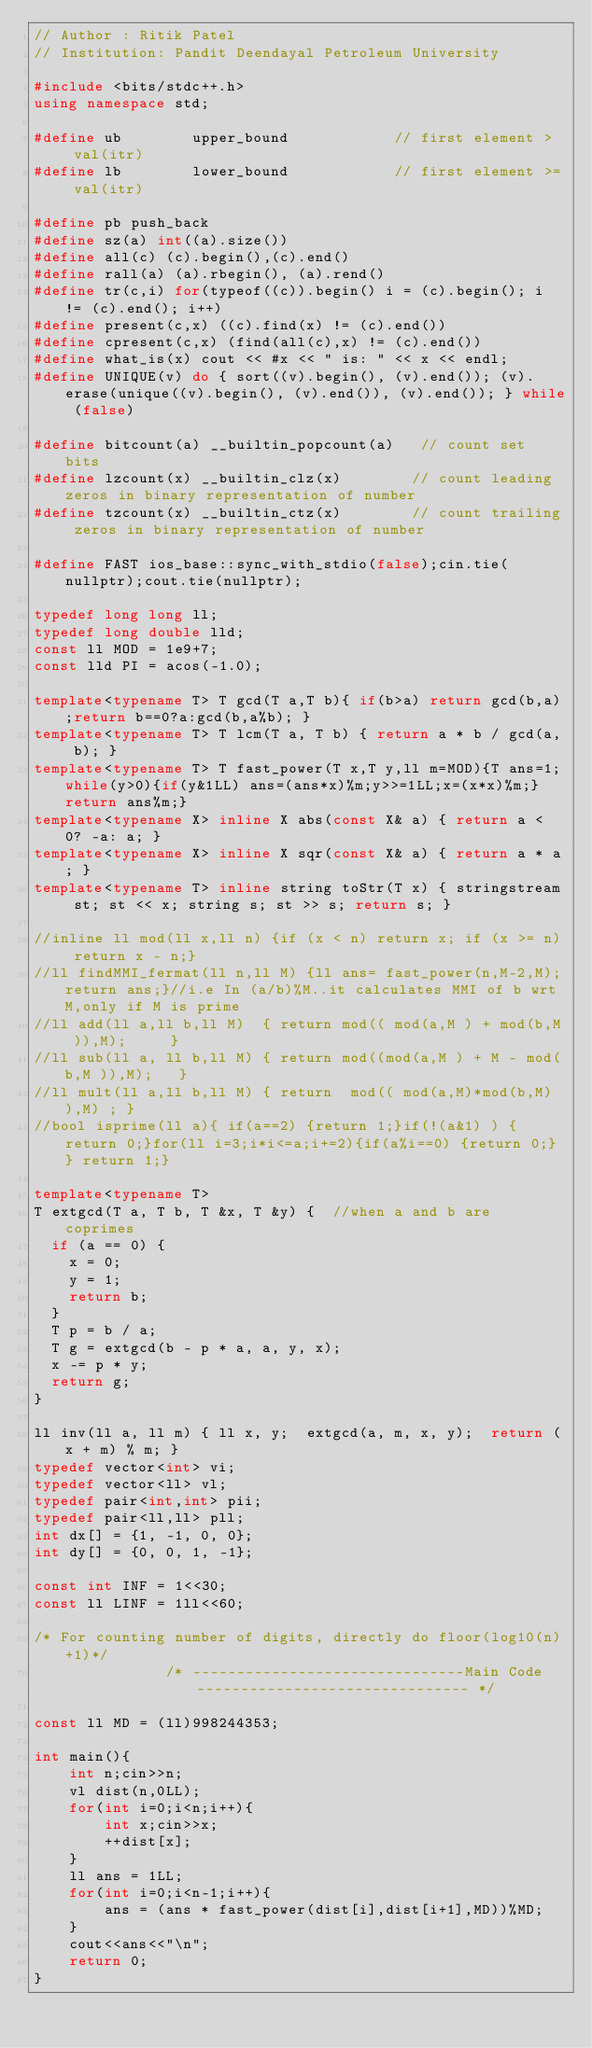<code> <loc_0><loc_0><loc_500><loc_500><_C++_>// Author : Ritik Patel
// Institution: Pandit Deendayal Petroleum University
 
#include <bits/stdc++.h>
using namespace std;
 
#define ub        upper_bound            // first element >  val(itr)
#define lb        lower_bound            // first element >= val(itr)
 
#define pb push_back 
#define sz(a) int((a).size())
#define all(c) (c).begin(),(c).end()
#define rall(a) (a).rbegin(), (a).rend()
#define tr(c,i) for(typeof((c)).begin() i = (c).begin(); i != (c).end(); i++)
#define present(c,x) ((c).find(x) != (c).end()) 
#define cpresent(c,x) (find(all(c),x) != (c).end()) 
#define what_is(x) cout << #x << " is: " << x << endl;
#define UNIQUE(v) do { sort((v).begin(), (v).end()); (v).erase(unique((v).begin(), (v).end()), (v).end()); } while (false)
 
#define bitcount(a) __builtin_popcount(a)   // count set bits
#define lzcount(x) __builtin_clz(x)        // count leading zeros in binary representation of number
#define tzcount(x) __builtin_ctz(x)        // count trailing zeros in binary representation of number
 
#define FAST ios_base::sync_with_stdio(false);cin.tie(nullptr);cout.tie(nullptr);
 
typedef long long ll;
typedef long double lld;
const ll MOD = 1e9+7;
const lld PI = acos(-1.0);
 
template<typename T> T gcd(T a,T b){ if(b>a) return gcd(b,a);return b==0?a:gcd(b,a%b); }
template<typename T> T lcm(T a, T b) { return a * b / gcd(a, b); }
template<typename T> T fast_power(T x,T y,ll m=MOD){T ans=1;while(y>0){if(y&1LL) ans=(ans*x)%m;y>>=1LL;x=(x*x)%m;}return ans%m;}
template<typename X> inline X abs(const X& a) { return a < 0? -a: a; }
template<typename X> inline X sqr(const X& a) { return a * a; }
template<typename T> inline string toStr(T x) { stringstream st; st << x; string s; st >> s; return s; }
 
//inline ll mod(ll x,ll n) {if (x < n) return x; if (x >= n) return x - n;}
//ll findMMI_fermat(ll n,ll M) {ll ans= fast_power(n,M-2,M);return ans;}//i.e In (a/b)%M..it calculates MMI of b wrt M,only if M is prime
//ll add(ll a,ll b,ll M)  { return mod(( mod(a,M ) + mod(b,M )),M);     }
//ll sub(ll a, ll b,ll M) { return mod((mod(a,M ) + M - mod(b,M )),M);   }
//ll mult(ll a,ll b,ll M) { return  mod(( mod(a,M)*mod(b,M) ),M) ; }
//bool isprime(ll a){ if(a==2) {return 1;}if(!(a&1) ) {return 0;}for(ll i=3;i*i<=a;i+=2){if(a%i==0) {return 0;} } return 1;} 
 
template<typename T>
T extgcd(T a, T b, T &x, T &y) {  //when a and b are coprimes
  if (a == 0) {
    x = 0;
    y = 1;
    return b;
  }
  T p = b / a;
  T g = extgcd(b - p * a, a, y, x);
  x -= p * y;
  return g;
}
 
ll inv(ll a, ll m) { ll x, y;  extgcd(a, m, x, y);  return (x + m) % m; }
typedef vector<int> vi;
typedef vector<ll> vl;
typedef pair<int,int> pii;
typedef pair<ll,ll> pll; 
int dx[] = {1, -1, 0, 0};
int dy[] = {0, 0, 1, -1};

const int INF = 1<<30;
const ll LINF = 1ll<<60;
 
/* For counting number of digits, directly do floor(log10(n)+1)*/
               /* -------------------------------Main Code------------------------------- */

const ll MD = (ll)998244353;
 
int main(){
    int n;cin>>n;
    vl dist(n,0LL);
    for(int i=0;i<n;i++){
        int x;cin>>x;
        ++dist[x];
    }
    ll ans = 1LL;
    for(int i=0;i<n-1;i++){
        ans = (ans * fast_power(dist[i],dist[i+1],MD))%MD;
    }
    cout<<ans<<"\n";
    return 0;
}
</code> 